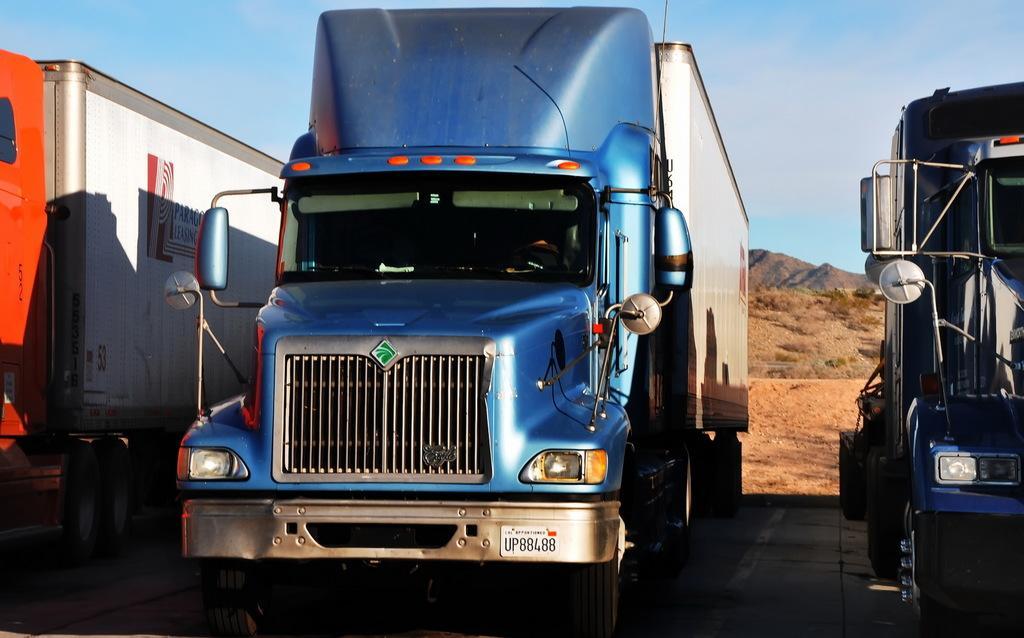Can you describe this image briefly? In this image we can see some trucks on the ground. On the backside we can see some plants, the hills and the sky which looks cloudy. 